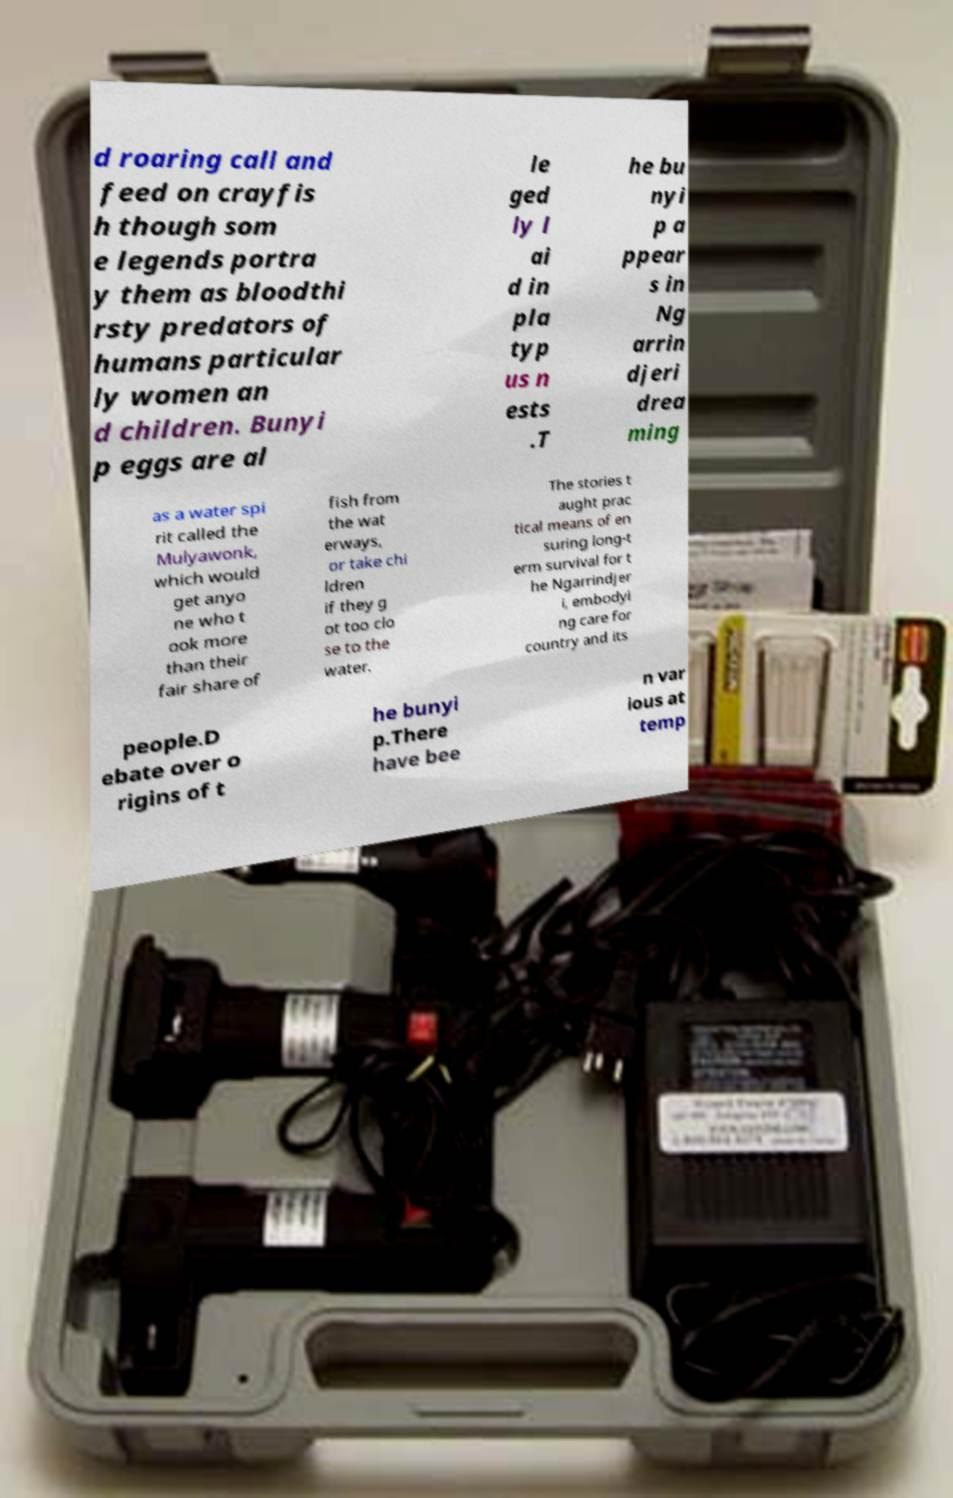I need the written content from this picture converted into text. Can you do that? d roaring call and feed on crayfis h though som e legends portra y them as bloodthi rsty predators of humans particular ly women an d children. Bunyi p eggs are al le ged ly l ai d in pla typ us n ests .T he bu nyi p a ppear s in Ng arrin djeri drea ming as a water spi rit called the Mulyawonk, which would get anyo ne who t ook more than their fair share of fish from the wat erways, or take chi ldren if they g ot too clo se to the water. The stories t aught prac tical means of en suring long-t erm survival for t he Ngarrindjer i, embodyi ng care for country and its people.D ebate over o rigins of t he bunyi p.There have bee n var ious at temp 